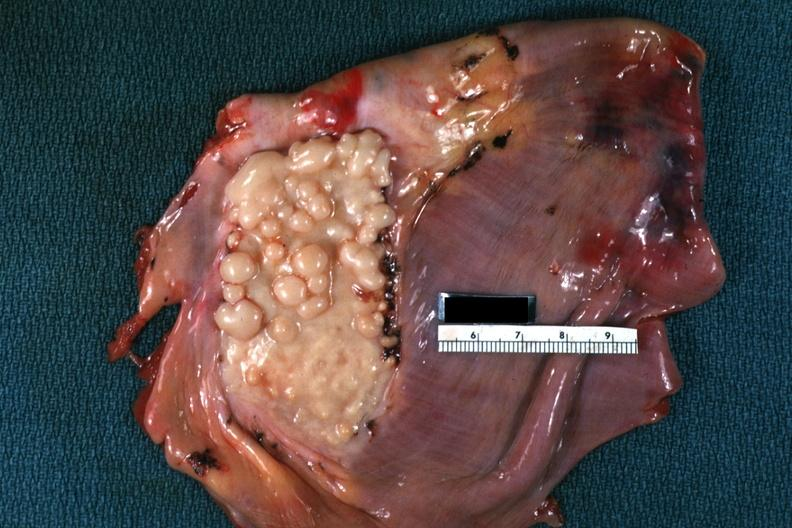does this image show plaque like lesion quite good?
Answer the question using a single word or phrase. Yes 